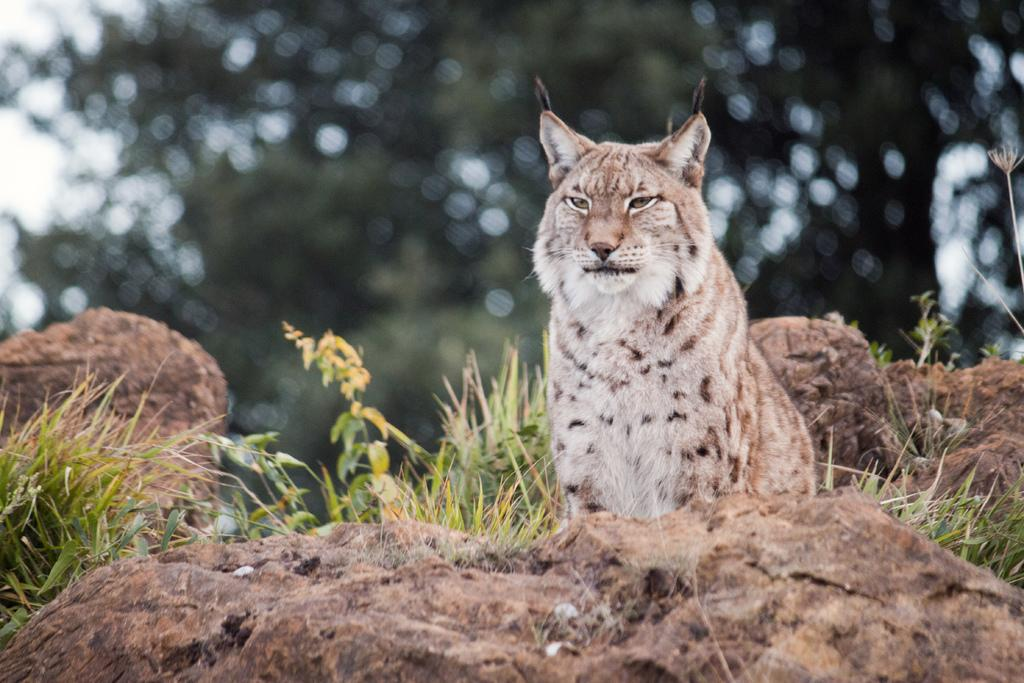What animal is in the image? There is a lynx in the image. Where is the lynx located? The lynx is sitting on a path. What is in front of the lynx? There are rocks in front of the lynx. What is behind the lynx? There are trees behind the lynx. What can be seen in the sky in the image? The sky is visible in the image. What type of spy equipment can be seen in the image? There is no spy equipment present in the image; it features a lynx sitting on a path with rocks and trees in the background. 